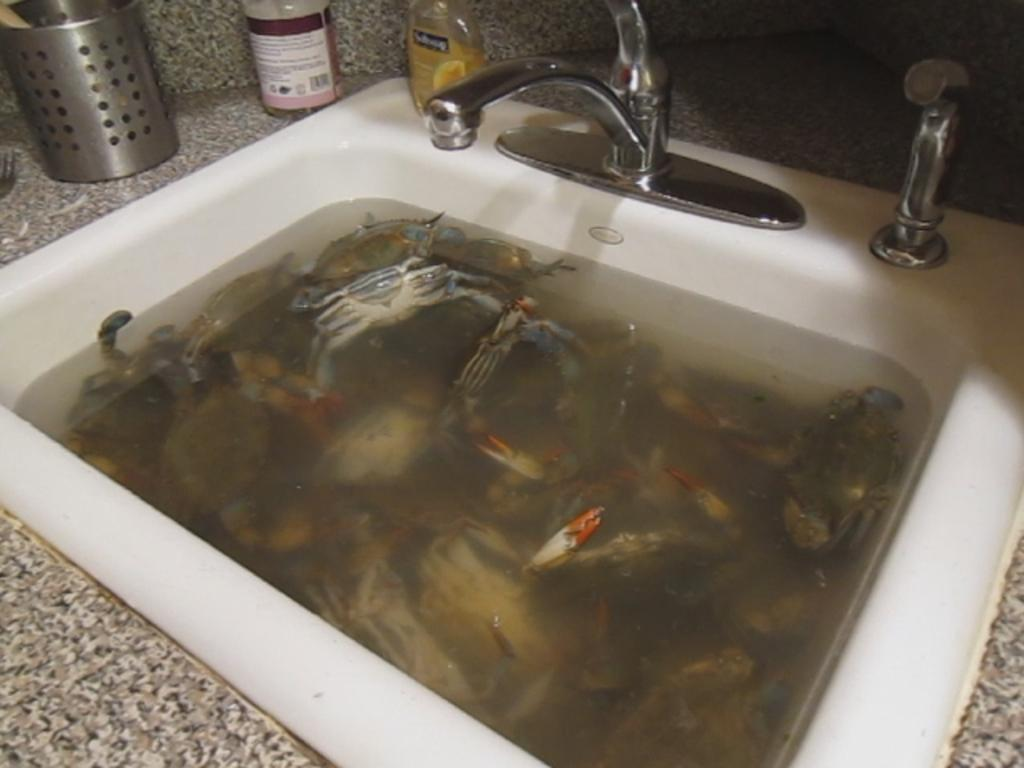What can be found in the image that is used for washing or cleaning? There is a sink in the image that can be used for washing or cleaning. What is inside the sink in the image? There are crabs in water inside the sink. How is water supplied to the sink? There is a tap on the sink that supplies water. What else can be seen on the sink? There are bottles on the sink. What object in the image has holes in it? There is an object with holes in the image, which might be a colander or a similar kitchen tool. What type of treatment is being administered to the crabs in the image? There is no treatment being administered to the crabs in the image; they are simply in water inside the sink. What type of flower can be seen in the image? There is no flower present in the image. 